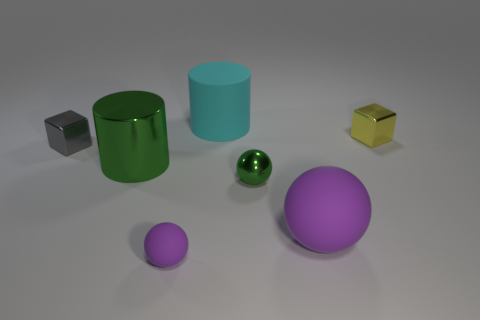How many other objects are there of the same material as the green ball?
Give a very brief answer. 3. Is the number of rubber spheres that are left of the large matte cylinder the same as the number of big rubber objects left of the big purple sphere?
Your answer should be compact. Yes. There is a small metallic object that is to the left of the purple matte object on the left side of the large thing that is behind the small yellow metal cube; what is its color?
Your answer should be compact. Gray. What is the shape of the purple matte thing that is in front of the big rubber ball?
Your answer should be compact. Sphere. There is a large purple thing that is the same material as the big cyan cylinder; what is its shape?
Offer a terse response. Sphere. Is there any other thing that is the same shape as the tiny purple object?
Make the answer very short. Yes. There is a gray thing; how many cyan cylinders are to the right of it?
Give a very brief answer. 1. Are there the same number of yellow shiny objects left of the big cyan cylinder and tiny purple spheres?
Your answer should be very brief. No. Do the small gray object and the tiny yellow object have the same material?
Keep it short and to the point. Yes. What is the size of the shiny object that is left of the big matte ball and behind the large green object?
Ensure brevity in your answer.  Small. 